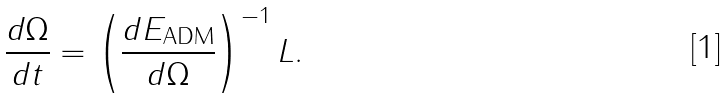Convert formula to latex. <formula><loc_0><loc_0><loc_500><loc_500>\frac { d \Omega } { d t } = \left ( \frac { d E _ { \text {ADM} } } { d \Omega } \right ) ^ { - 1 } L .</formula> 